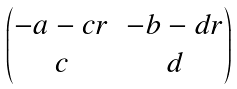<formula> <loc_0><loc_0><loc_500><loc_500>\begin{pmatrix} - a - c r & - b - d r \\ c & d \\ \end{pmatrix}</formula> 